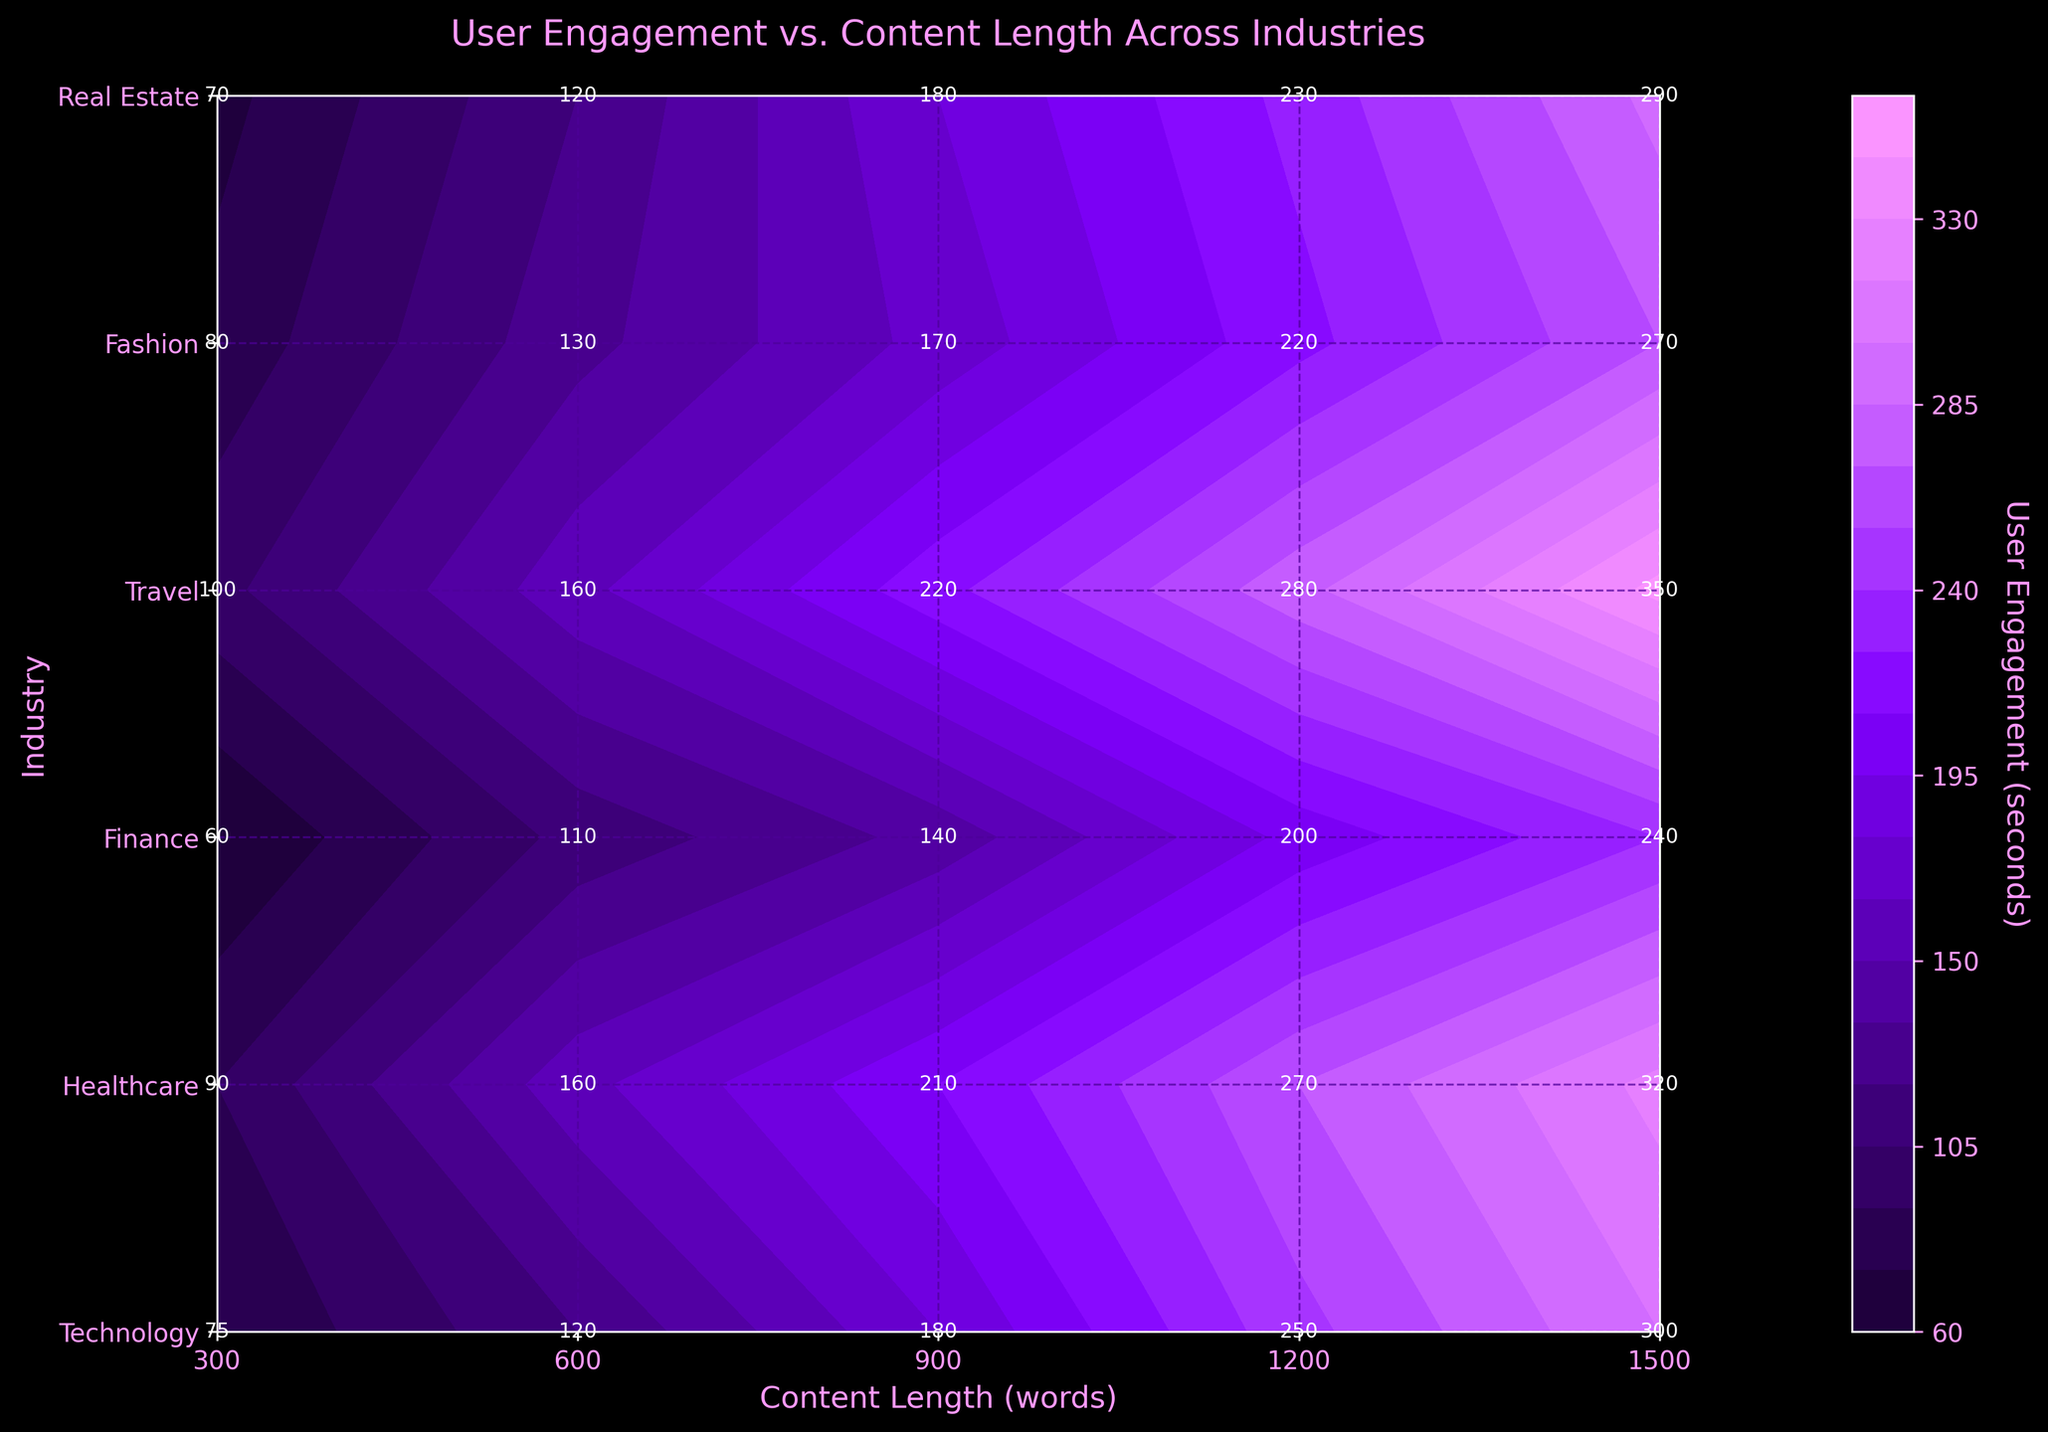What is the title of the figure? The title of the figure is located at the top and is denoted by the largest text. It helps in summarizing the main theme of the figure.
Answer: User Engagement vs. Content Length Across Industries How many industries are displayed in the figure? The industries are listed along the y-axis. By counting the labels, one can determine the number of distinct industries.
Answer: 6 Which industry shows the highest user engagement for the longest content length? By looking at the y-axis for industries and finding the highest user engagement peak along the x-axis (longest content length), we can determine the industry with the maximum user engagement.
Answer: Travel What is the user engagement for the fashion industry at 600 words? Locate the intersection of the Fashion row on the y-axis and the 600 words mark on the x-axis to find the user engagement value at this point.
Answer: 130 seconds Compare the user engagement between Technology and Healthcare at 1200 words. For each industry, locate the corresponding engagement values at 1200 words on the x-axis and compare them.
Answer: Technology: 250 seconds, Healthcare: 270 seconds What pattern do you observe in user engagement as content length increases for the Finance industry? Observe the trend of the engagement values for the Finance row across increasing content length on the x-axis. This will show how engagement changes as content length increases.
Answer: It generally increases What is the difference in user engagement between Real Estate at 900 words and Travel at 900 words? Identify the engagement values for both industries at 900 words on the x-axis and calculate the difference.
Answer: 40 seconds (220 - 180) Which industry has the lowest user engagement at the shortest content length? Find the industry with the lowest engagement value at the 300 words mark on the x-axis.
Answer: Finance Does user engagement for the Technology industry increase consistently with content length, or are there any significant drops? Analyze the engagement points for Technology at each content length interval on the x-axis to see if engagement consistently increases.
Answer: It increases consistently What is the average user engagement for Healthcare for content lengths of 300, 600, and 900 words combined? Add the engagement values for Healthcare at 300, 600, and 900 words, then divide by 3 to get the average.
Answer: 153.33 seconds (90+160+210)/3 